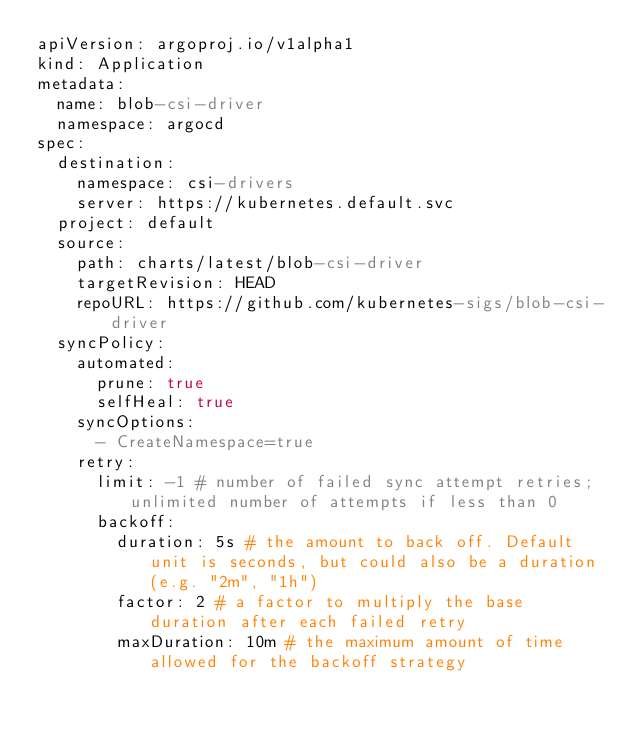<code> <loc_0><loc_0><loc_500><loc_500><_YAML_>apiVersion: argoproj.io/v1alpha1
kind: Application
metadata:
  name: blob-csi-driver
  namespace: argocd
spec:
  destination:
    namespace: csi-drivers
    server: https://kubernetes.default.svc
  project: default
  source:
    path: charts/latest/blob-csi-driver
    targetRevision: HEAD
    repoURL: https://github.com/kubernetes-sigs/blob-csi-driver
  syncPolicy:
    automated:
      prune: true
      selfHeal: true
    syncOptions:
      - CreateNamespace=true
    retry:
      limit: -1 # number of failed sync attempt retries; unlimited number of attempts if less than 0
      backoff:
        duration: 5s # the amount to back off. Default unit is seconds, but could also be a duration (e.g. "2m", "1h")
        factor: 2 # a factor to multiply the base duration after each failed retry
        maxDuration: 10m # the maximum amount of time allowed for the backoff strategy
</code> 